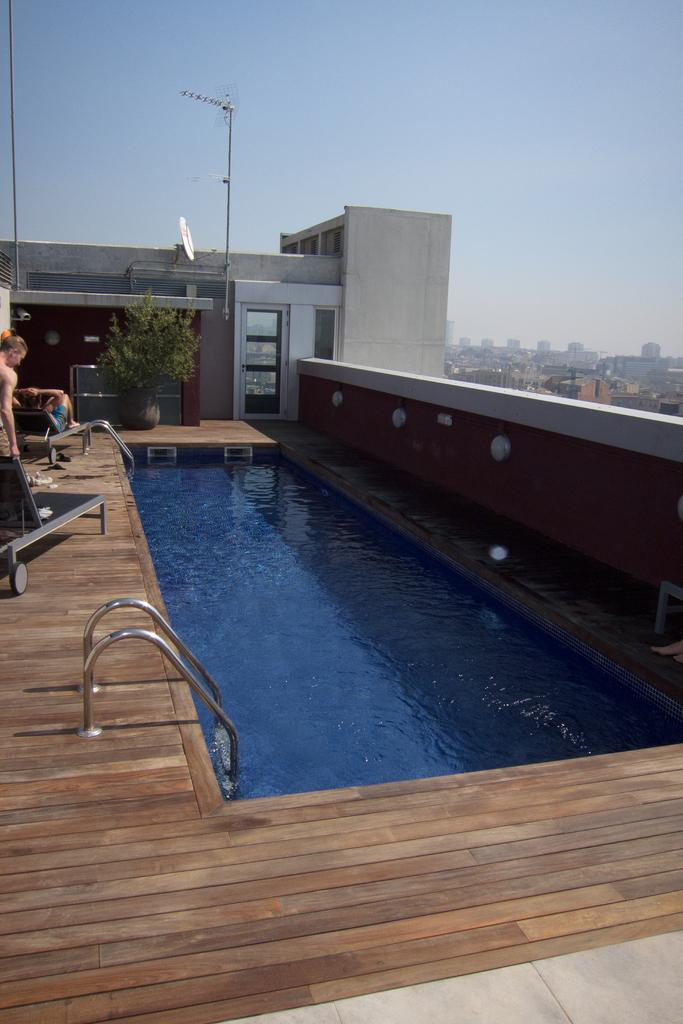What is the main feature of the image? There is a swimming pool in the image. What type of furniture is present in the image? There are chairs in the image. What kind of plant can be seen in the image? There is a house plant in the image. How many people are in the image? There are two persons in the image. What type of structures are visible in the image? There are buildings in the image. What can be seen in the background of the image? The sky is visible in the background of the image. What type of canvas is being used by the person in the image? There is no canvas or person painting in the image; it features a swimming pool, chairs, a house plant, two persons, buildings, and the sky in the background. Can you tell me when the birth of the baby in the image took place? There is no baby or birth depicted in the image; it features a swimming pool, chairs, a house plant, two persons, buildings, and the sky in the background. 